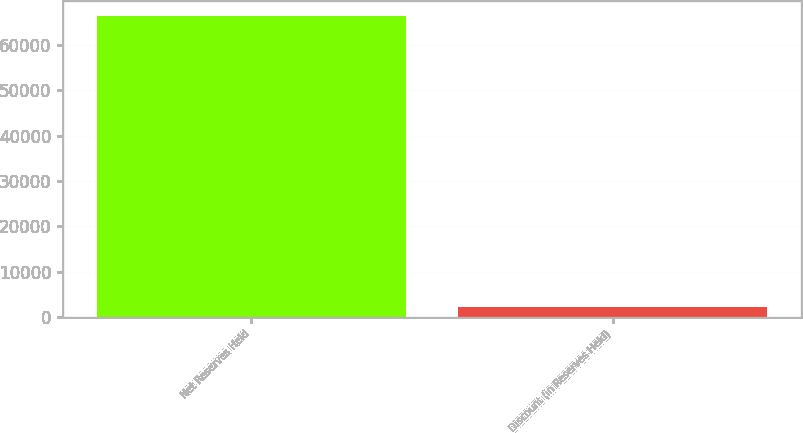Convert chart to OTSL. <chart><loc_0><loc_0><loc_500><loc_500><bar_chart><fcel>Net Reserves Held<fcel>Discount (in Reserves Held)<nl><fcel>66496.1<fcel>2264<nl></chart> 